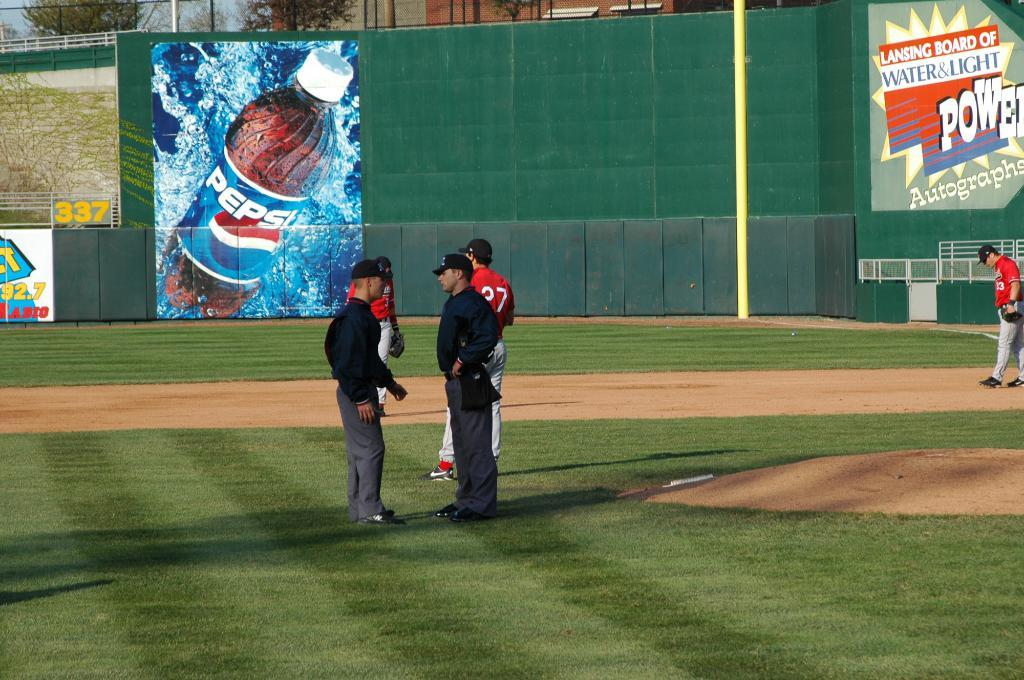<image>
Describe the image concisely. Behind the players and umpires is a big Pepsi advertisement. 